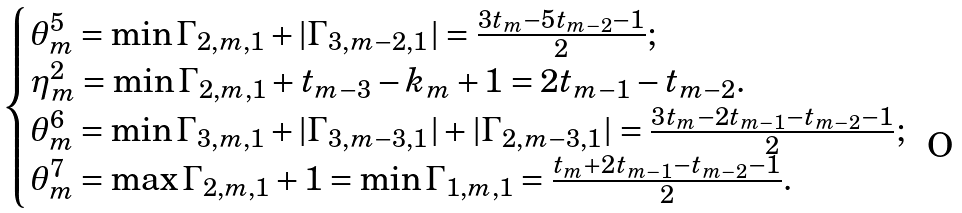<formula> <loc_0><loc_0><loc_500><loc_500>\begin{cases} \theta _ { m } ^ { 5 } = \min \Gamma _ { 2 , m , 1 } + | \Gamma _ { 3 , m - 2 , 1 } | = \frac { 3 t _ { m } - 5 t _ { m - 2 } - 1 } { 2 } ; \\ \eta _ { m } ^ { 2 } = \min \Gamma _ { 2 , m , 1 } + t _ { m - 3 } - k _ { m } + 1 = 2 t _ { m - 1 } - t _ { m - 2 } . \\ \theta _ { m } ^ { 6 } = \min \Gamma _ { 3 , m , 1 } + | \Gamma _ { 3 , m - 3 , 1 } | + | \Gamma _ { 2 , m - 3 , 1 } | = \frac { 3 t _ { m } - 2 t _ { m - 1 } - t _ { m - 2 } - 1 } { 2 } ; \\ \theta _ { m } ^ { 7 } = \max \Gamma _ { 2 , m , 1 } + 1 = \min \Gamma _ { 1 , m , 1 } = \frac { t _ { m } + 2 t _ { m - 1 } - t _ { m - 2 } - 1 } { 2 } . \end{cases}</formula> 